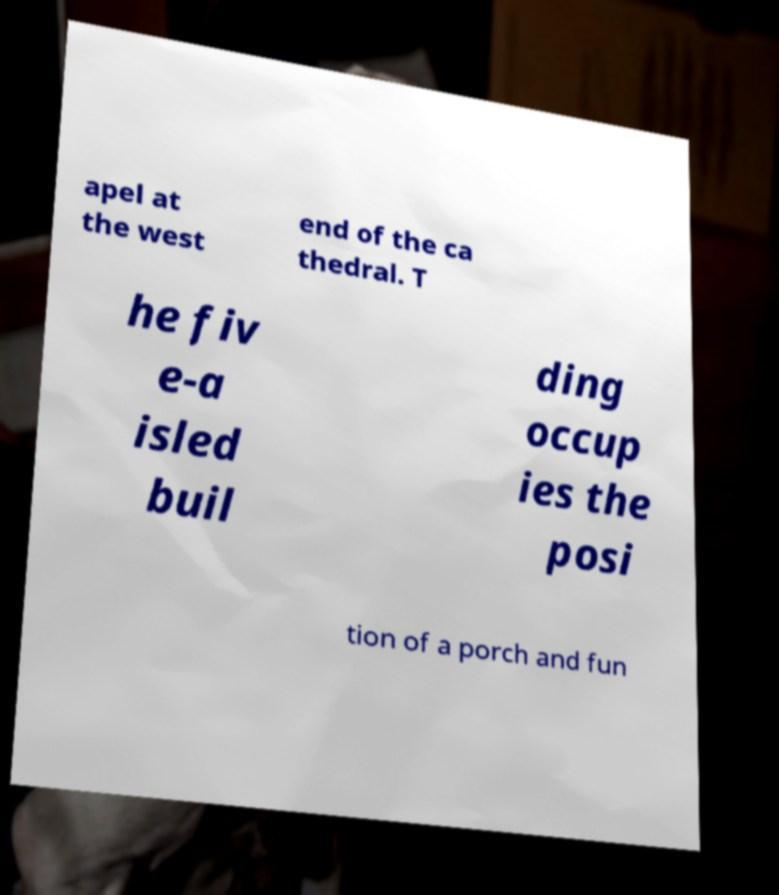For documentation purposes, I need the text within this image transcribed. Could you provide that? apel at the west end of the ca thedral. T he fiv e-a isled buil ding occup ies the posi tion of a porch and fun 